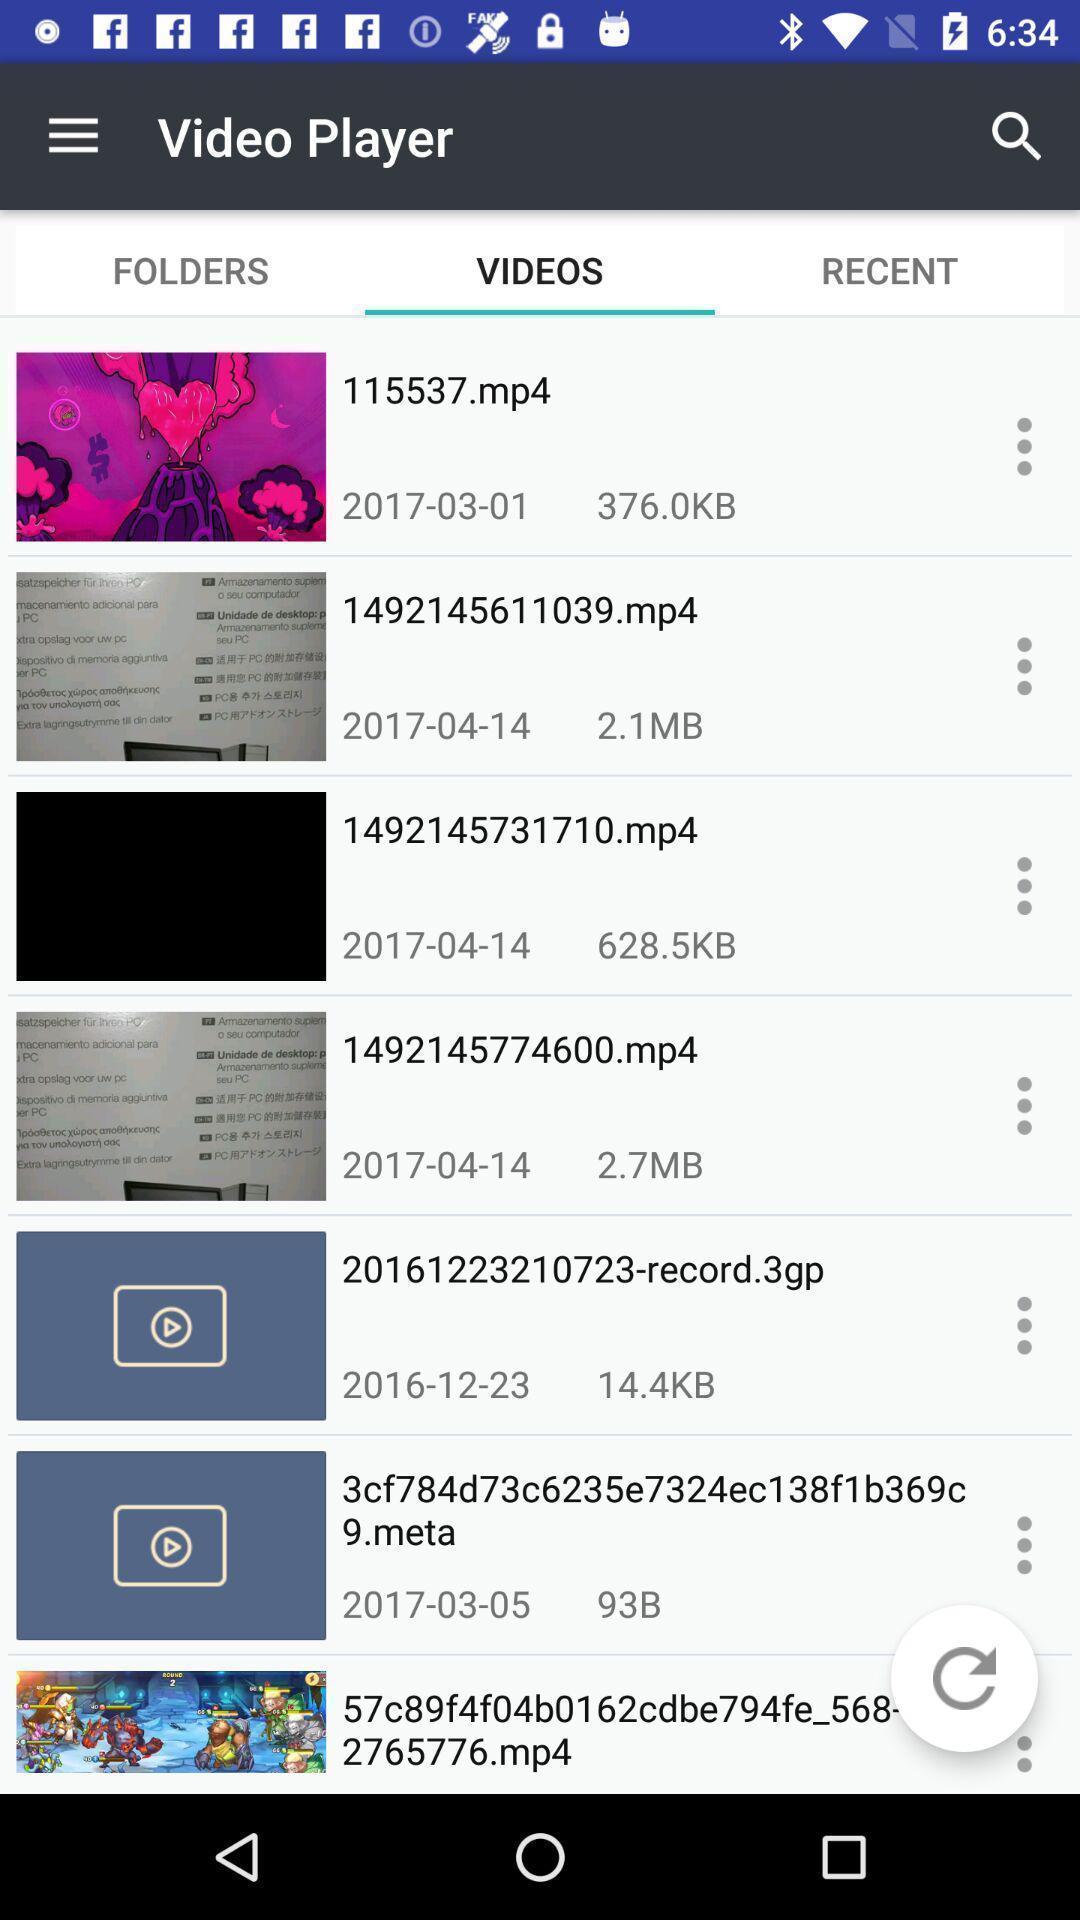Describe the key features of this screenshot. Screen showing the listings in videos tab. 